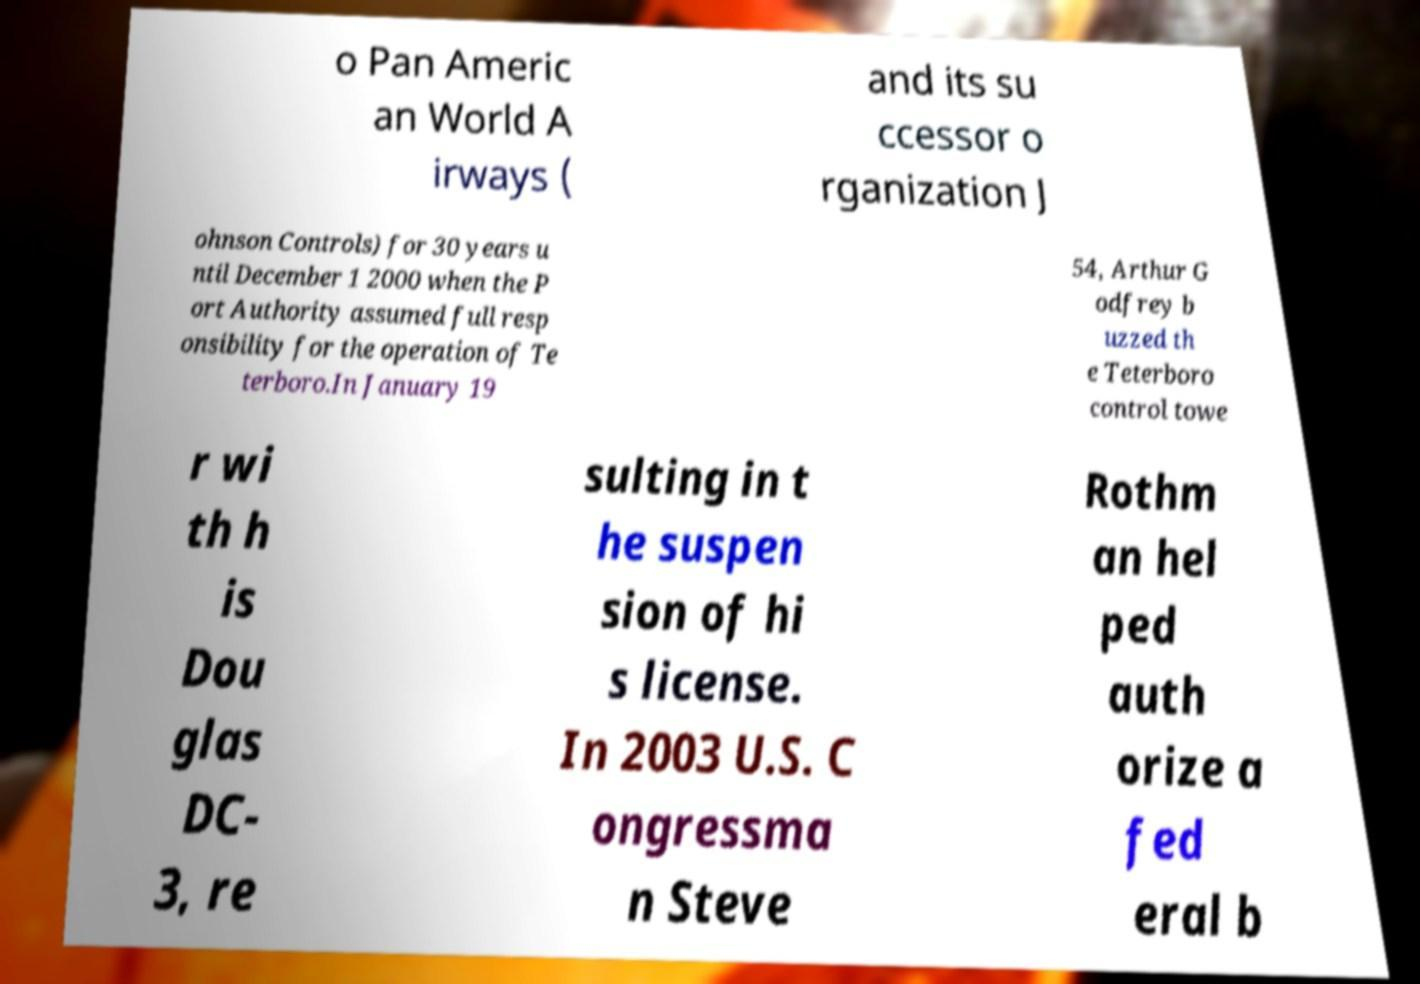Can you accurately transcribe the text from the provided image for me? o Pan Americ an World A irways ( and its su ccessor o rganization J ohnson Controls) for 30 years u ntil December 1 2000 when the P ort Authority assumed full resp onsibility for the operation of Te terboro.In January 19 54, Arthur G odfrey b uzzed th e Teterboro control towe r wi th h is Dou glas DC- 3, re sulting in t he suspen sion of hi s license. In 2003 U.S. C ongressma n Steve Rothm an hel ped auth orize a fed eral b 